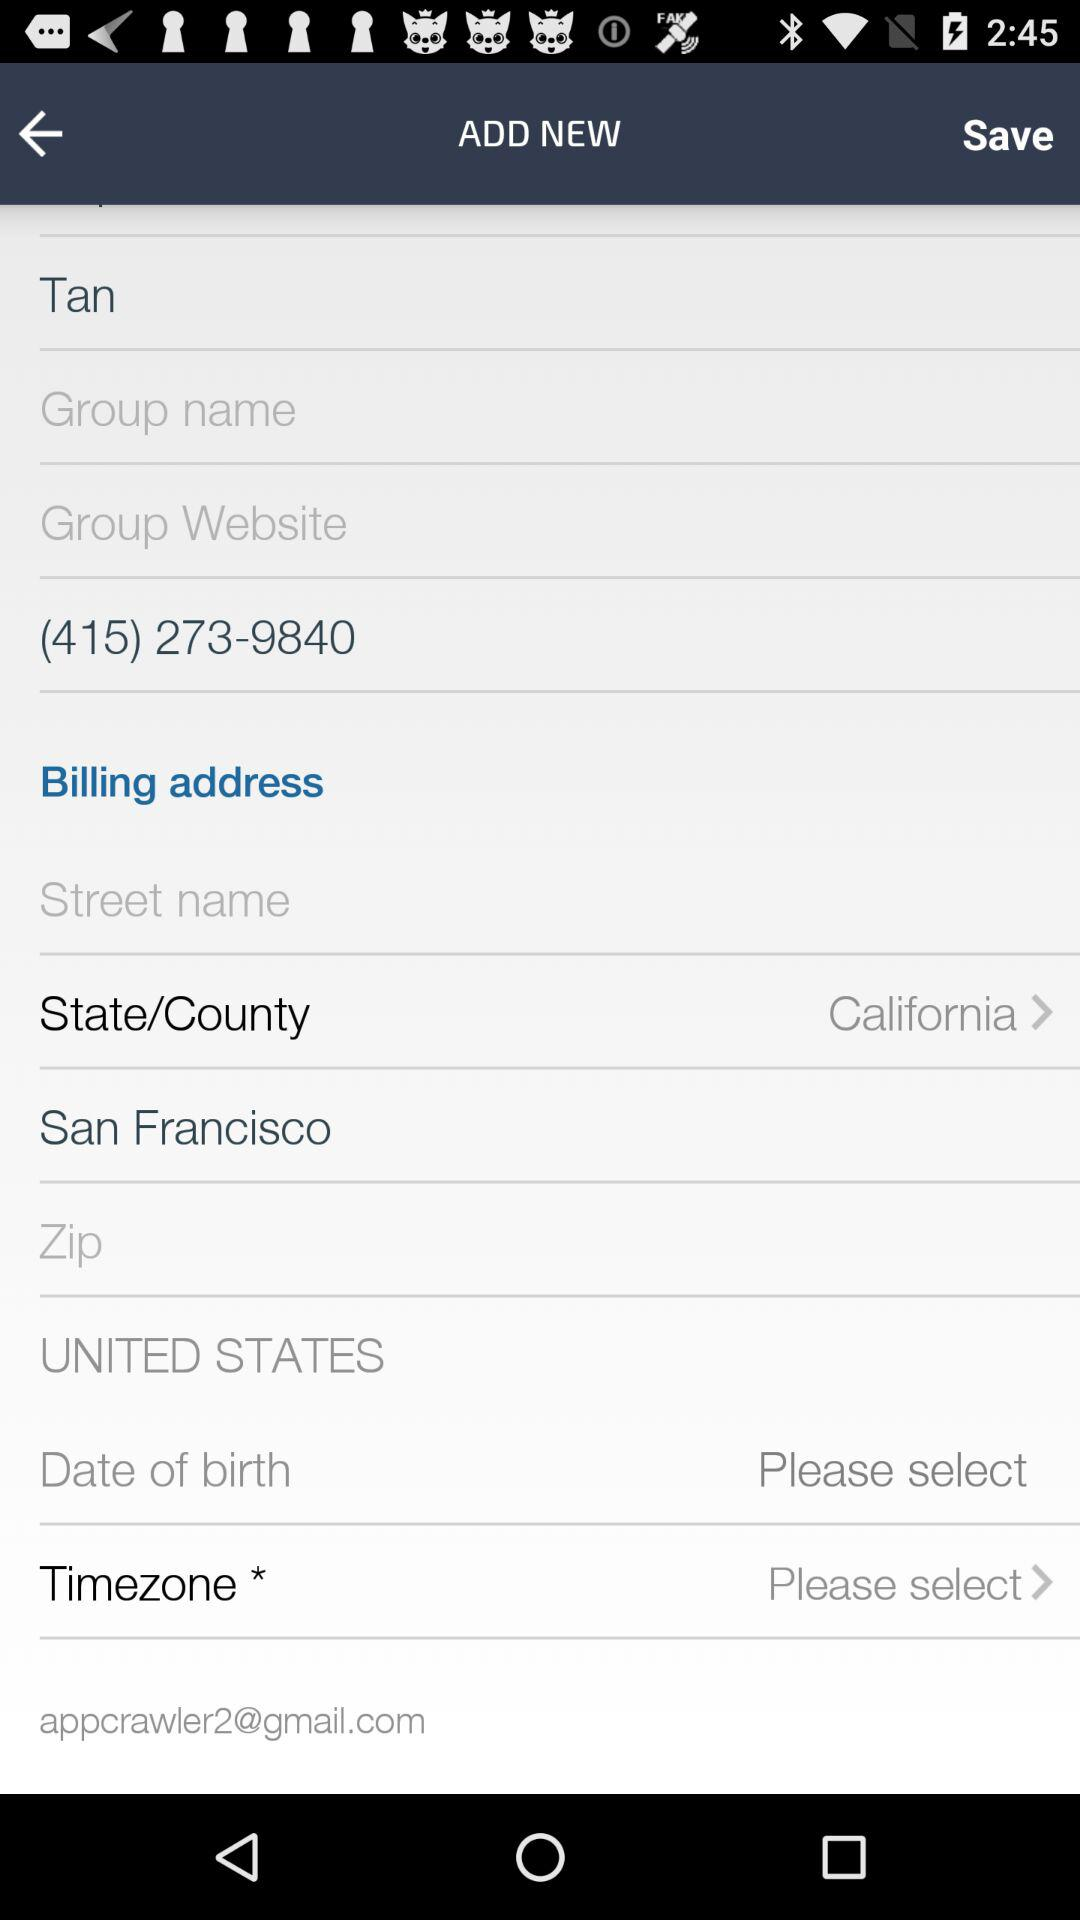What state is selected? The selected state is California. 